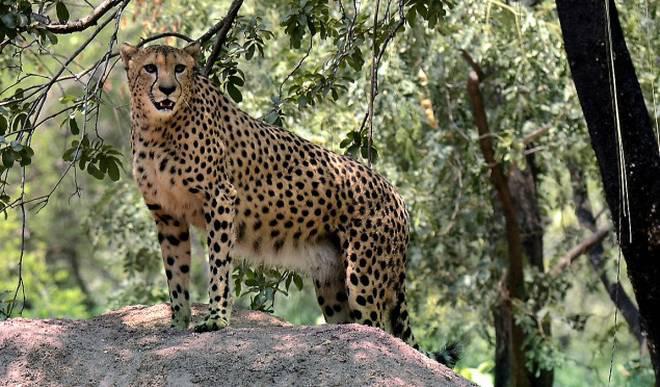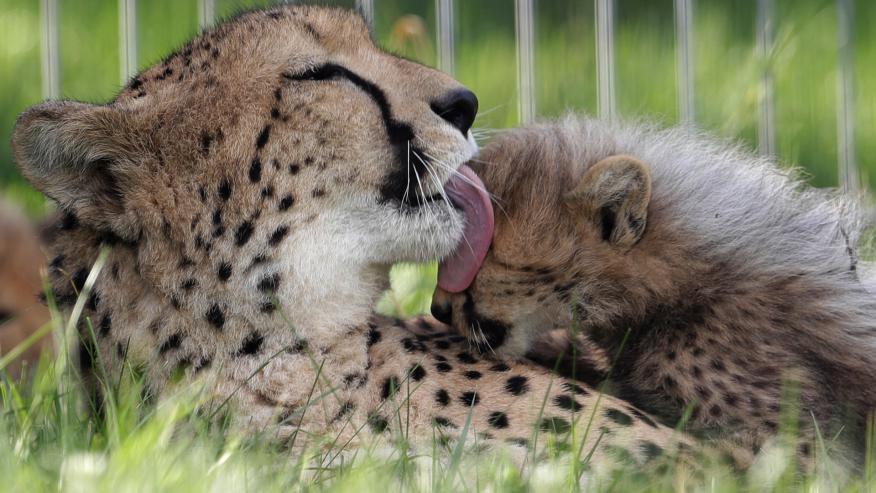The first image is the image on the left, the second image is the image on the right. Assess this claim about the two images: "The left image contains one cheetah, an adult lying on the ground, and the other image features a reclining adult cheetah with its head facing forward on the right, and a cheetah kitten in front of it with its head turned forward on the left.". Correct or not? Answer yes or no. No. The first image is the image on the left, the second image is the image on the right. Considering the images on both sides, is "Three cats are lying down, with more in the image on the right." valid? Answer yes or no. No. 